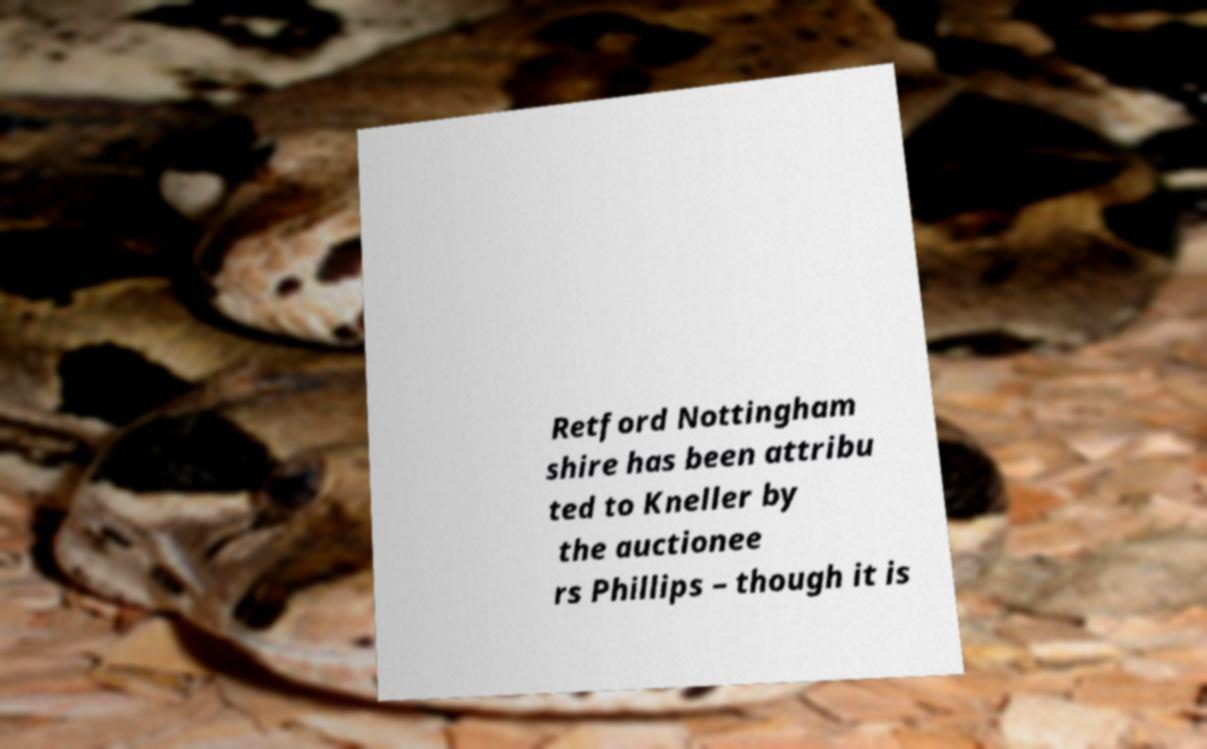What messages or text are displayed in this image? I need them in a readable, typed format. Retford Nottingham shire has been attribu ted to Kneller by the auctionee rs Phillips – though it is 